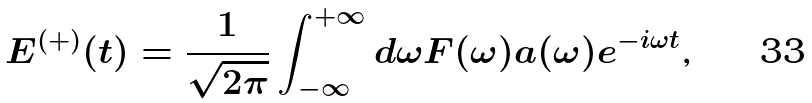Convert formula to latex. <formula><loc_0><loc_0><loc_500><loc_500>E ^ { ( + ) } ( t ) = \frac { 1 } { \sqrt { 2 \pi } } \int _ { - \infty } ^ { + \infty } d \omega F ( \omega ) a ( \omega ) e ^ { - i \omega t } \text {,}</formula> 